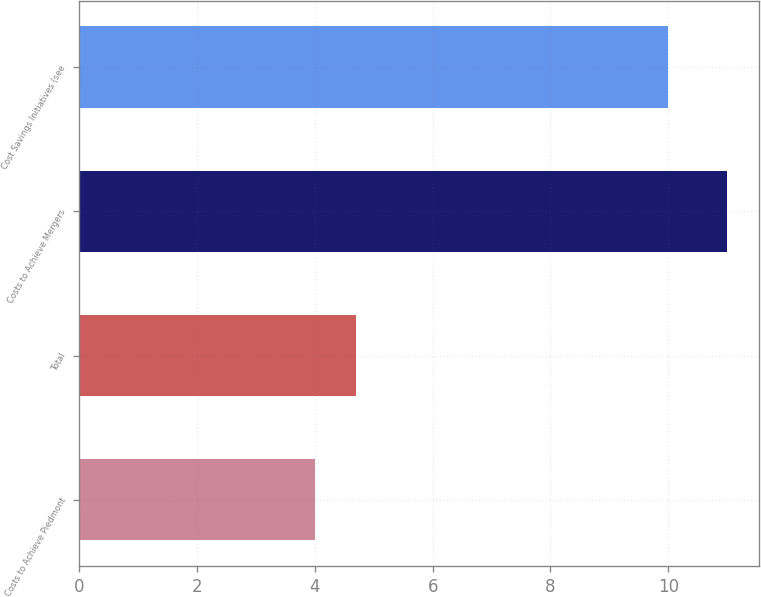Convert chart to OTSL. <chart><loc_0><loc_0><loc_500><loc_500><bar_chart><fcel>Costs to Achieve Piedmont<fcel>Total<fcel>Costs to Achieve Mergers<fcel>Cost Savings Initiatives (see<nl><fcel>4<fcel>4.7<fcel>11<fcel>10<nl></chart> 